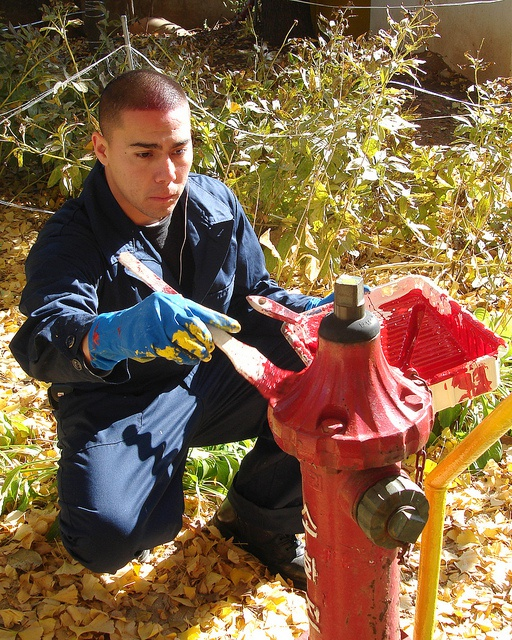Describe the objects in this image and their specific colors. I can see people in black, brown, darkgray, and white tones and fire hydrant in black, brown, and maroon tones in this image. 